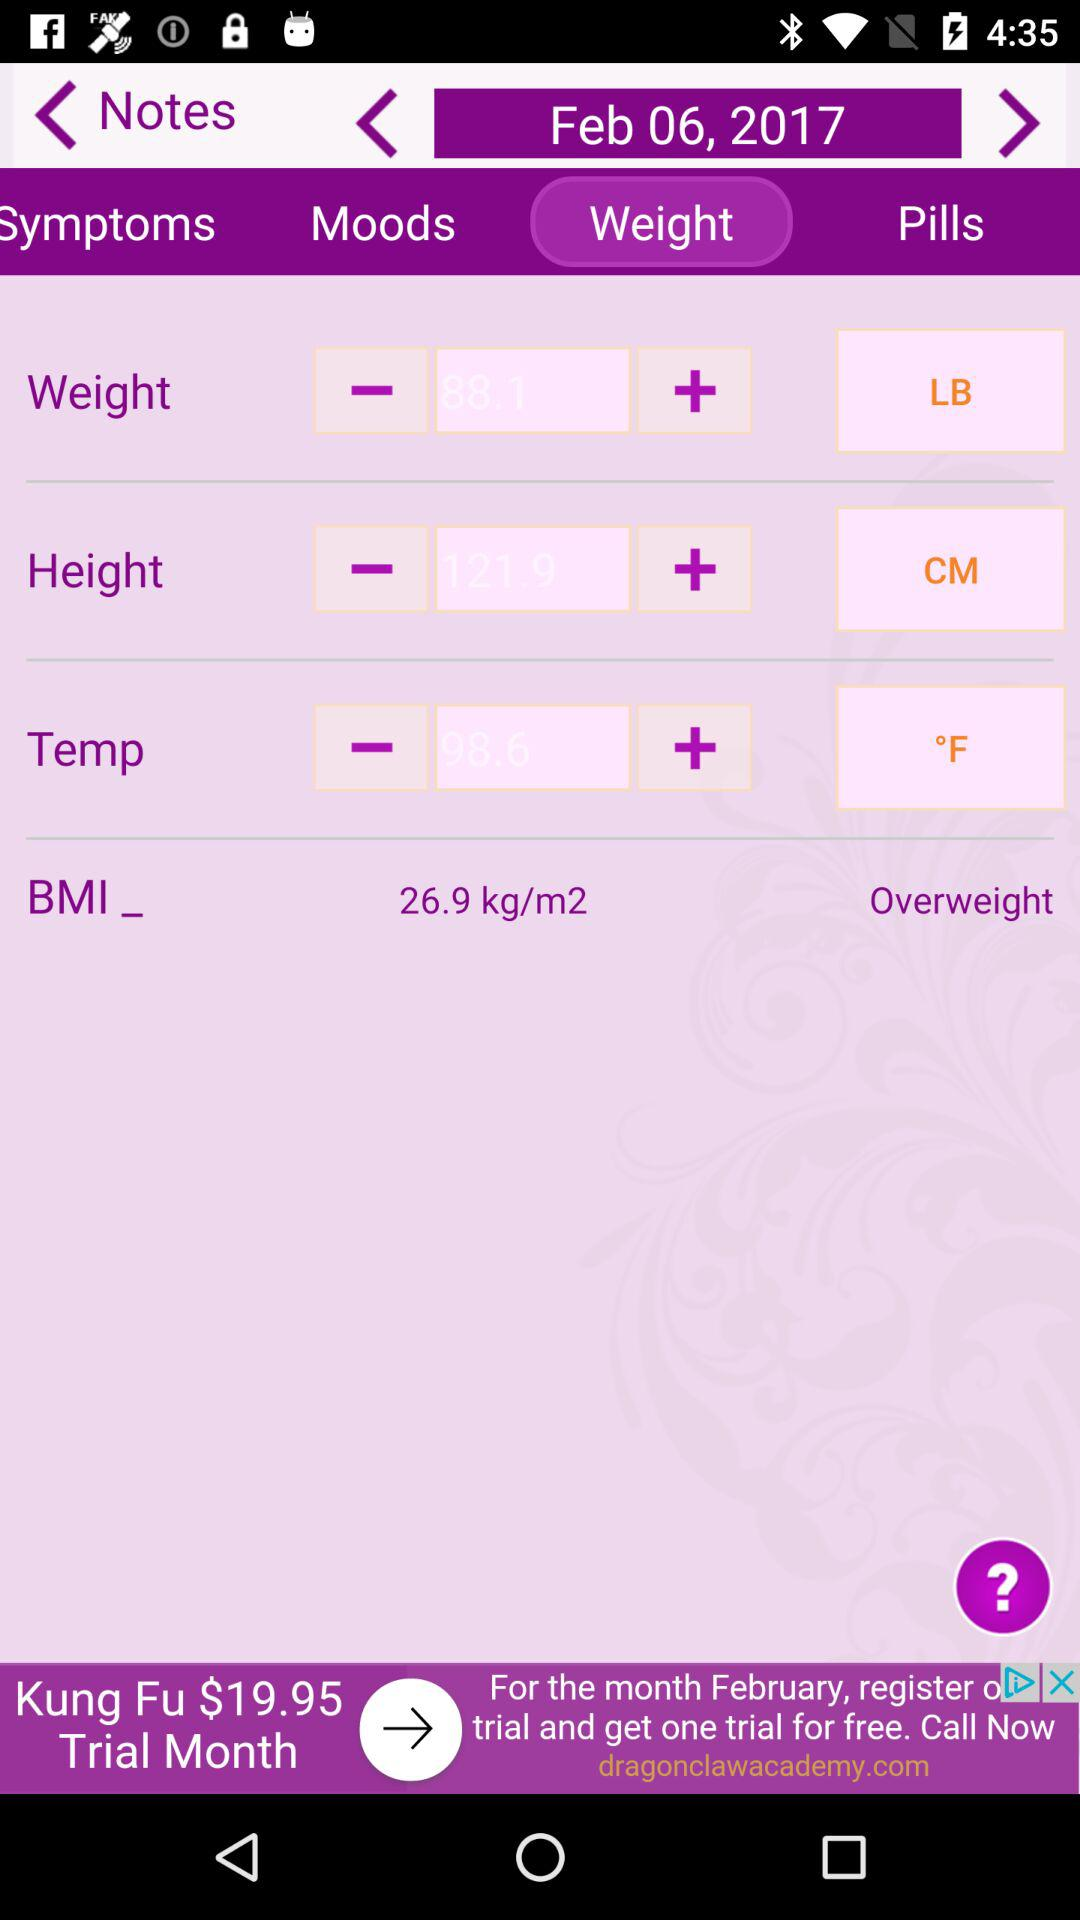Which is the selected tab? The selected tab is "Weight". 